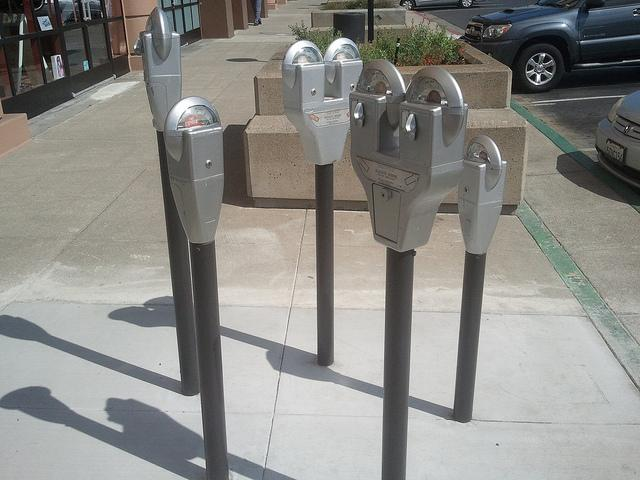How many cars do these meters currently monitor? Please explain your reasoning. none. Because of there position it is easy to surmise that there are no cars being used for it. 